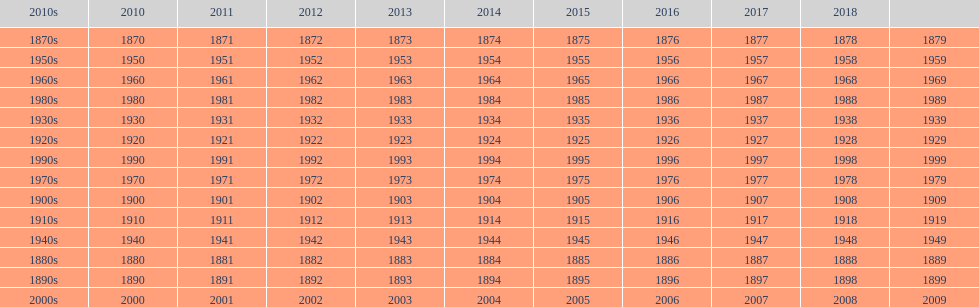Mathematically speaking, what is the difference between 2015 and 1912? 103. 